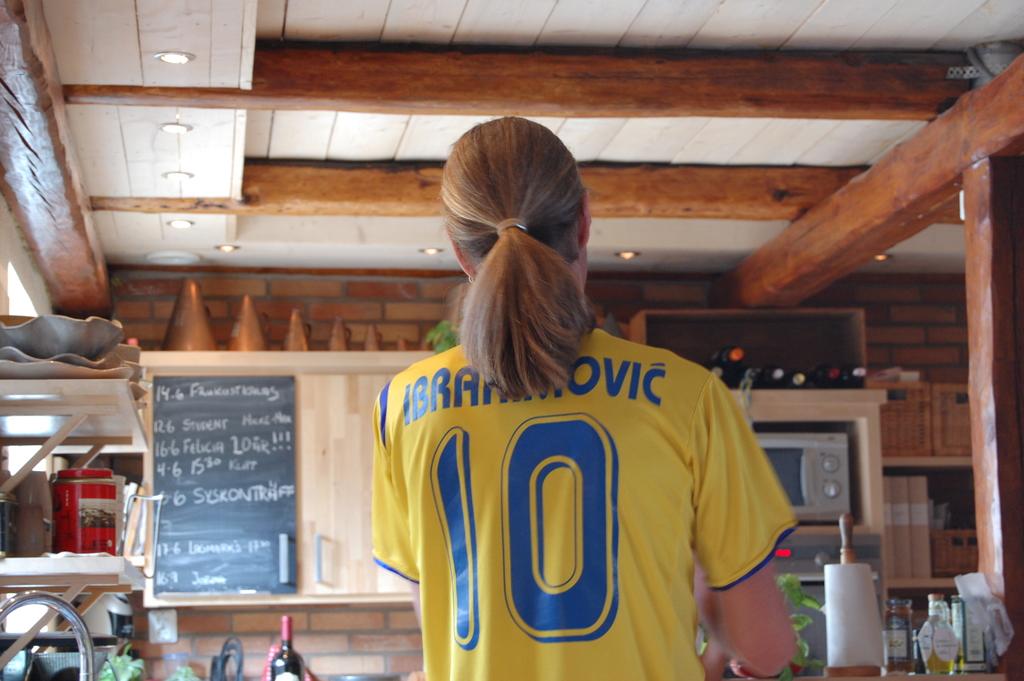What is this players number?
Offer a very short reply. 10. 